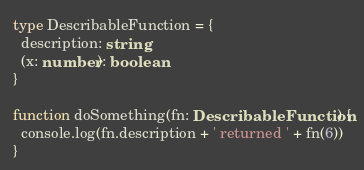<code> <loc_0><loc_0><loc_500><loc_500><_TypeScript_>type DescribableFunction = {
  description: string
  (x: number): boolean
}

function doSomething(fn: DescribableFunction) {
  console.log(fn.description + ' returned ' + fn(6))
}
</code> 